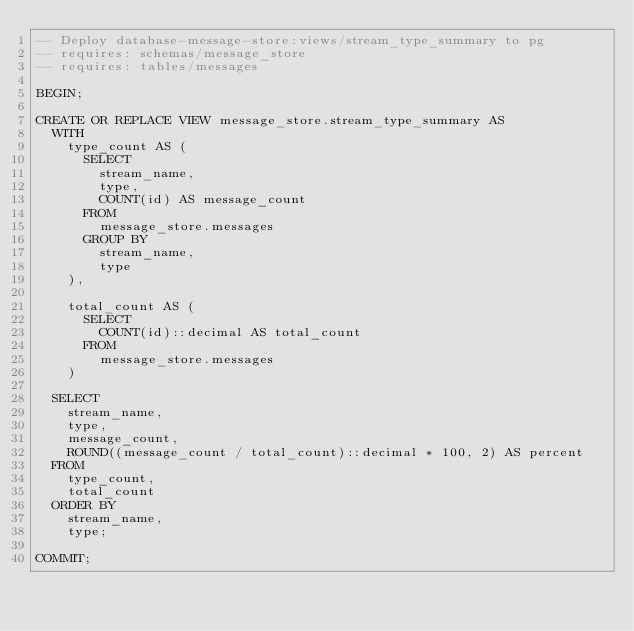<code> <loc_0><loc_0><loc_500><loc_500><_SQL_>-- Deploy database-message-store:views/stream_type_summary to pg
-- requires: schemas/message_store
-- requires: tables/messages

BEGIN;

CREATE OR REPLACE VIEW message_store.stream_type_summary AS
  WITH
    type_count AS (
      SELECT
        stream_name,
        type,
        COUNT(id) AS message_count
      FROM
        message_store.messages
      GROUP BY
        stream_name,
        type
    ),

    total_count AS (
      SELECT
        COUNT(id)::decimal AS total_count
      FROM
        message_store.messages
    )

  SELECT
    stream_name,
    type,
    message_count,
    ROUND((message_count / total_count)::decimal * 100, 2) AS percent
  FROM
    type_count,
    total_count
  ORDER BY
    stream_name,
    type;

COMMIT;
</code> 